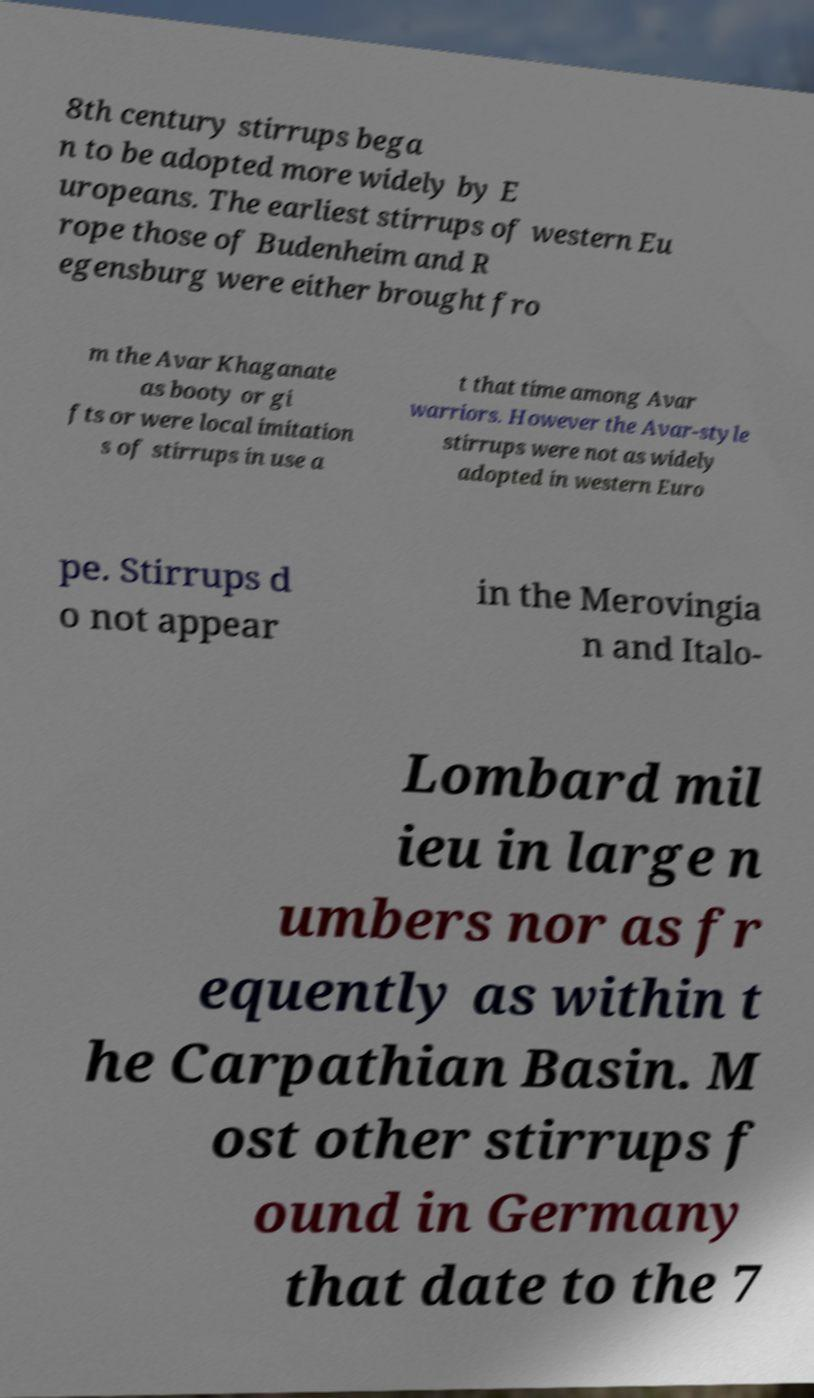Could you extract and type out the text from this image? 8th century stirrups bega n to be adopted more widely by E uropeans. The earliest stirrups of western Eu rope those of Budenheim and R egensburg were either brought fro m the Avar Khaganate as booty or gi fts or were local imitation s of stirrups in use a t that time among Avar warriors. However the Avar-style stirrups were not as widely adopted in western Euro pe. Stirrups d o not appear in the Merovingia n and Italo- Lombard mil ieu in large n umbers nor as fr equently as within t he Carpathian Basin. M ost other stirrups f ound in Germany that date to the 7 